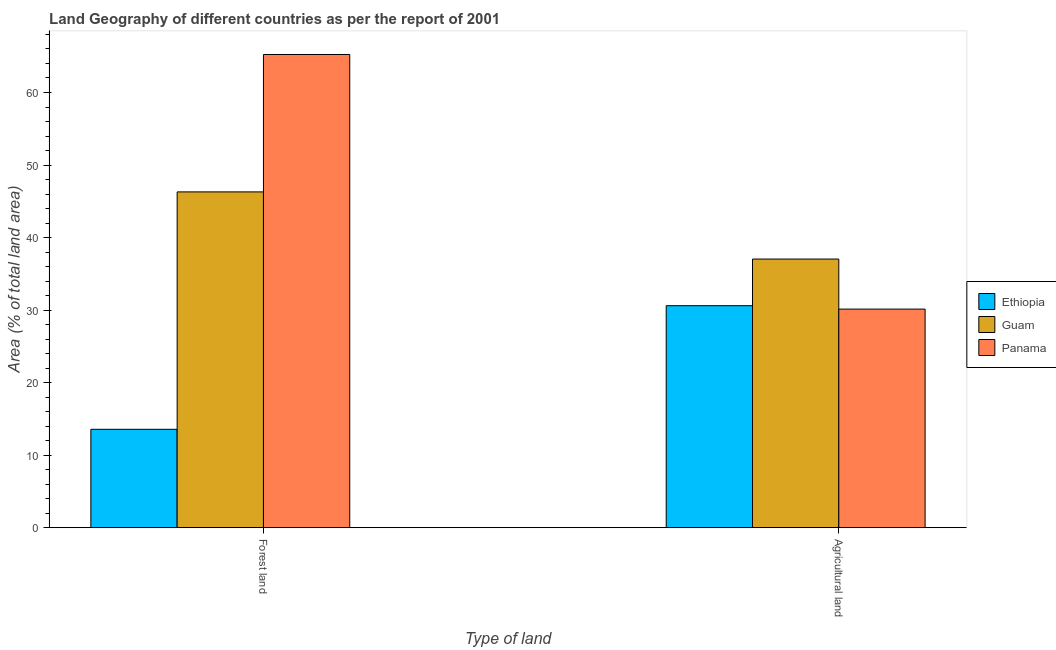How many different coloured bars are there?
Offer a very short reply. 3. How many bars are there on the 2nd tick from the left?
Give a very brief answer. 3. How many bars are there on the 2nd tick from the right?
Offer a very short reply. 3. What is the label of the 1st group of bars from the left?
Your answer should be compact. Forest land. What is the percentage of land area under forests in Guam?
Provide a succinct answer. 46.3. Across all countries, what is the maximum percentage of land area under agriculture?
Offer a very short reply. 37.04. Across all countries, what is the minimum percentage of land area under agriculture?
Provide a short and direct response. 30.14. In which country was the percentage of land area under forests maximum?
Make the answer very short. Panama. In which country was the percentage of land area under forests minimum?
Your answer should be very brief. Ethiopia. What is the total percentage of land area under agriculture in the graph?
Offer a terse response. 97.78. What is the difference between the percentage of land area under agriculture in Guam and that in Panama?
Make the answer very short. 6.9. What is the difference between the percentage of land area under agriculture in Panama and the percentage of land area under forests in Guam?
Offer a very short reply. -16.16. What is the average percentage of land area under forests per country?
Provide a short and direct response. 41.7. What is the difference between the percentage of land area under forests and percentage of land area under agriculture in Ethiopia?
Ensure brevity in your answer.  -17.04. In how many countries, is the percentage of land area under forests greater than 54 %?
Your answer should be very brief. 1. What is the ratio of the percentage of land area under forests in Ethiopia to that in Panama?
Make the answer very short. 0.21. Is the percentage of land area under forests in Guam less than that in Ethiopia?
Ensure brevity in your answer.  No. What does the 1st bar from the left in Forest land represents?
Keep it short and to the point. Ethiopia. What does the 2nd bar from the right in Forest land represents?
Provide a succinct answer. Guam. How many bars are there?
Keep it short and to the point. 6. Are all the bars in the graph horizontal?
Your answer should be very brief. No. How many countries are there in the graph?
Ensure brevity in your answer.  3. What is the difference between two consecutive major ticks on the Y-axis?
Provide a succinct answer. 10. Where does the legend appear in the graph?
Give a very brief answer. Center right. How many legend labels are there?
Your answer should be very brief. 3. What is the title of the graph?
Offer a terse response. Land Geography of different countries as per the report of 2001. What is the label or title of the X-axis?
Provide a succinct answer. Type of land. What is the label or title of the Y-axis?
Offer a terse response. Area (% of total land area). What is the Area (% of total land area) of Ethiopia in Forest land?
Ensure brevity in your answer.  13.56. What is the Area (% of total land area) in Guam in Forest land?
Your response must be concise. 46.3. What is the Area (% of total land area) in Panama in Forest land?
Keep it short and to the point. 65.24. What is the Area (% of total land area) in Ethiopia in Agricultural land?
Your answer should be compact. 30.61. What is the Area (% of total land area) in Guam in Agricultural land?
Keep it short and to the point. 37.04. What is the Area (% of total land area) in Panama in Agricultural land?
Offer a terse response. 30.14. Across all Type of land, what is the maximum Area (% of total land area) in Ethiopia?
Provide a short and direct response. 30.61. Across all Type of land, what is the maximum Area (% of total land area) in Guam?
Your answer should be compact. 46.3. Across all Type of land, what is the maximum Area (% of total land area) of Panama?
Your answer should be compact. 65.24. Across all Type of land, what is the minimum Area (% of total land area) of Ethiopia?
Provide a short and direct response. 13.56. Across all Type of land, what is the minimum Area (% of total land area) of Guam?
Your answer should be compact. 37.04. Across all Type of land, what is the minimum Area (% of total land area) in Panama?
Provide a succinct answer. 30.14. What is the total Area (% of total land area) in Ethiopia in the graph?
Your answer should be compact. 44.17. What is the total Area (% of total land area) of Guam in the graph?
Keep it short and to the point. 83.33. What is the total Area (% of total land area) of Panama in the graph?
Offer a very short reply. 95.38. What is the difference between the Area (% of total land area) of Ethiopia in Forest land and that in Agricultural land?
Offer a terse response. -17.04. What is the difference between the Area (% of total land area) in Guam in Forest land and that in Agricultural land?
Offer a terse response. 9.26. What is the difference between the Area (% of total land area) of Panama in Forest land and that in Agricultural land?
Ensure brevity in your answer.  35.1. What is the difference between the Area (% of total land area) in Ethiopia in Forest land and the Area (% of total land area) in Guam in Agricultural land?
Provide a succinct answer. -23.47. What is the difference between the Area (% of total land area) of Ethiopia in Forest land and the Area (% of total land area) of Panama in Agricultural land?
Give a very brief answer. -16.57. What is the difference between the Area (% of total land area) of Guam in Forest land and the Area (% of total land area) of Panama in Agricultural land?
Ensure brevity in your answer.  16.16. What is the average Area (% of total land area) of Ethiopia per Type of land?
Offer a very short reply. 22.08. What is the average Area (% of total land area) of Guam per Type of land?
Your answer should be very brief. 41.67. What is the average Area (% of total land area) in Panama per Type of land?
Keep it short and to the point. 47.69. What is the difference between the Area (% of total land area) in Ethiopia and Area (% of total land area) in Guam in Forest land?
Your answer should be very brief. -32.73. What is the difference between the Area (% of total land area) in Ethiopia and Area (% of total land area) in Panama in Forest land?
Provide a succinct answer. -51.68. What is the difference between the Area (% of total land area) of Guam and Area (% of total land area) of Panama in Forest land?
Your response must be concise. -18.94. What is the difference between the Area (% of total land area) in Ethiopia and Area (% of total land area) in Guam in Agricultural land?
Make the answer very short. -6.43. What is the difference between the Area (% of total land area) of Ethiopia and Area (% of total land area) of Panama in Agricultural land?
Offer a terse response. 0.47. What is the difference between the Area (% of total land area) of Guam and Area (% of total land area) of Panama in Agricultural land?
Make the answer very short. 6.9. What is the ratio of the Area (% of total land area) in Ethiopia in Forest land to that in Agricultural land?
Offer a terse response. 0.44. What is the ratio of the Area (% of total land area) of Guam in Forest land to that in Agricultural land?
Offer a terse response. 1.25. What is the ratio of the Area (% of total land area) in Panama in Forest land to that in Agricultural land?
Offer a terse response. 2.16. What is the difference between the highest and the second highest Area (% of total land area) in Ethiopia?
Your response must be concise. 17.04. What is the difference between the highest and the second highest Area (% of total land area) of Guam?
Offer a terse response. 9.26. What is the difference between the highest and the second highest Area (% of total land area) of Panama?
Ensure brevity in your answer.  35.1. What is the difference between the highest and the lowest Area (% of total land area) of Ethiopia?
Offer a terse response. 17.04. What is the difference between the highest and the lowest Area (% of total land area) in Guam?
Provide a succinct answer. 9.26. What is the difference between the highest and the lowest Area (% of total land area) of Panama?
Your answer should be compact. 35.1. 